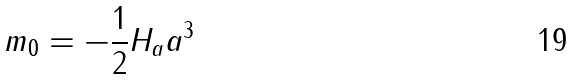Convert formula to latex. <formula><loc_0><loc_0><loc_500><loc_500>m _ { 0 } = - \frac { 1 } { 2 } H _ { a } a ^ { 3 }</formula> 